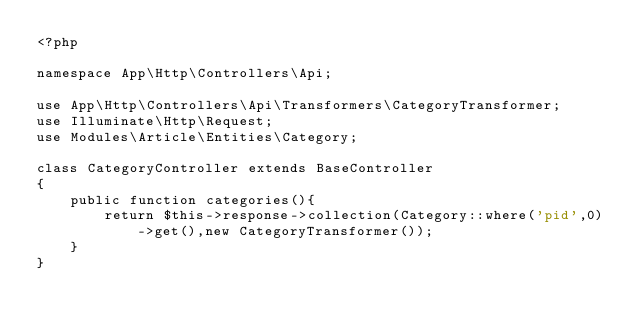Convert code to text. <code><loc_0><loc_0><loc_500><loc_500><_PHP_><?php

namespace App\Http\Controllers\Api;

use App\Http\Controllers\Api\Transformers\CategoryTransformer;
use Illuminate\Http\Request;
use Modules\Article\Entities\Category;

class CategoryController extends BaseController
{
    public function categories(){
        return $this->response->collection(Category::where('pid',0)->get(),new CategoryTransformer());
    }
}
</code> 